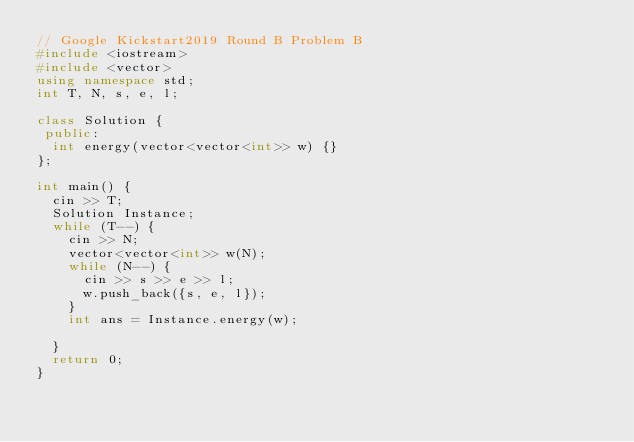<code> <loc_0><loc_0><loc_500><loc_500><_C++_>// Google Kickstart2019 Round B Problem B
#include <iostream>
#include <vector>
using namespace std;
int T, N, s, e, l;

class Solution {
 public:
  int energy(vector<vector<int>> w) {}
};

int main() {
  cin >> T;
  Solution Instance;
  while (T--) {
    cin >> N;
    vector<vector<int>> w(N);
    while (N--) {
      cin >> s >> e >> l;
      w.push_back({s, e, l});
    }
    int ans = Instance.energy(w);

  }
  return 0;
}</code> 